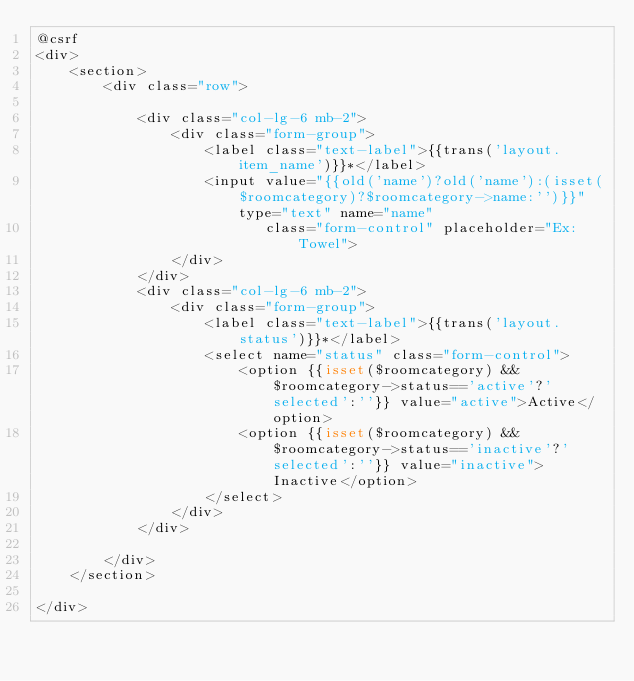Convert code to text. <code><loc_0><loc_0><loc_500><loc_500><_PHP_>@csrf
<div>
    <section>
        <div class="row">

            <div class="col-lg-6 mb-2">
                <div class="form-group">
                    <label class="text-label">{{trans('layout.item_name')}}*</label>
                    <input value="{{old('name')?old('name'):(isset($roomcategory)?$roomcategory->name:'')}}" type="text" name="name"
                           class="form-control" placeholder="Ex: Towel">
                </div>
            </div>
            <div class="col-lg-6 mb-2">
                <div class="form-group">
                    <label class="text-label">{{trans('layout.status')}}*</label>
                    <select name="status" class="form-control">
                        <option {{isset($roomcategory) && $roomcategory->status=='active'?'selected':''}} value="active">Active</option>
                        <option {{isset($roomcategory) && $roomcategory->status=='inactive'?'selected':''}} value="inactive">Inactive</option>
                    </select>
                </div>
            </div>

        </div>
    </section>

</div>
</code> 